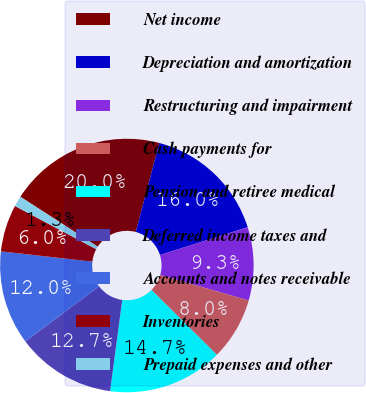<chart> <loc_0><loc_0><loc_500><loc_500><pie_chart><fcel>Net income<fcel>Depreciation and amortization<fcel>Restructuring and impairment<fcel>Cash payments for<fcel>Pension and retiree medical<fcel>Deferred income taxes and<fcel>Accounts and notes receivable<fcel>Inventories<fcel>Prepaid expenses and other<nl><fcel>20.0%<fcel>16.0%<fcel>9.33%<fcel>8.0%<fcel>14.67%<fcel>12.67%<fcel>12.0%<fcel>6.0%<fcel>1.34%<nl></chart> 